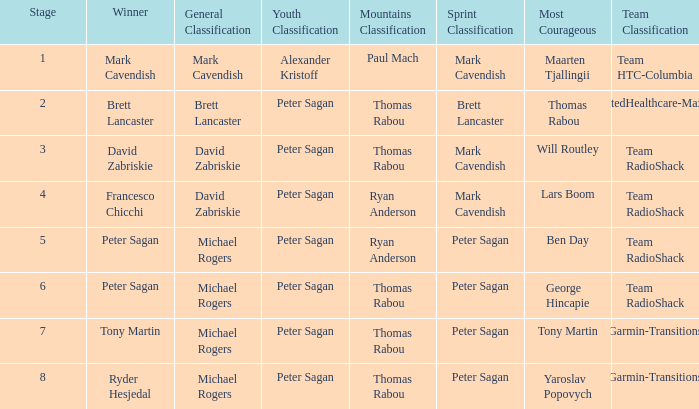When mark cavendish clinches sprint classification and maarten tjallingii captures most courageous, who attains youth classification? Alexander Kristoff. 